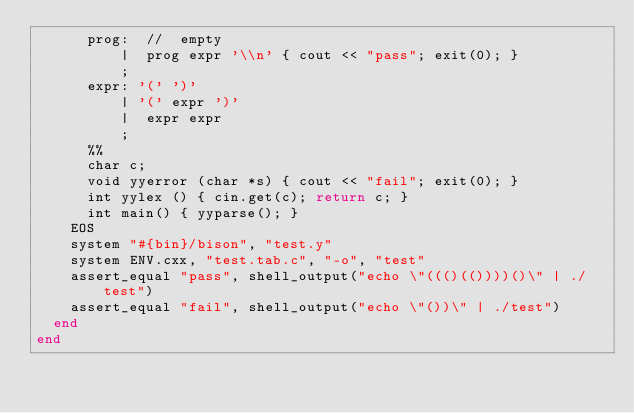<code> <loc_0><loc_0><loc_500><loc_500><_Ruby_>      prog:  //  empty
          |  prog expr '\\n' { cout << "pass"; exit(0); }
          ;
      expr: '(' ')'
          | '(' expr ')'
          |  expr expr
          ;
      %%
      char c;
      void yyerror (char *s) { cout << "fail"; exit(0); }
      int yylex () { cin.get(c); return c; }
      int main() { yyparse(); }
    EOS
    system "#{bin}/bison", "test.y"
    system ENV.cxx, "test.tab.c", "-o", "test"
    assert_equal "pass", shell_output("echo \"((()(())))()\" | ./test")
    assert_equal "fail", shell_output("echo \"())\" | ./test")
  end
end
</code> 